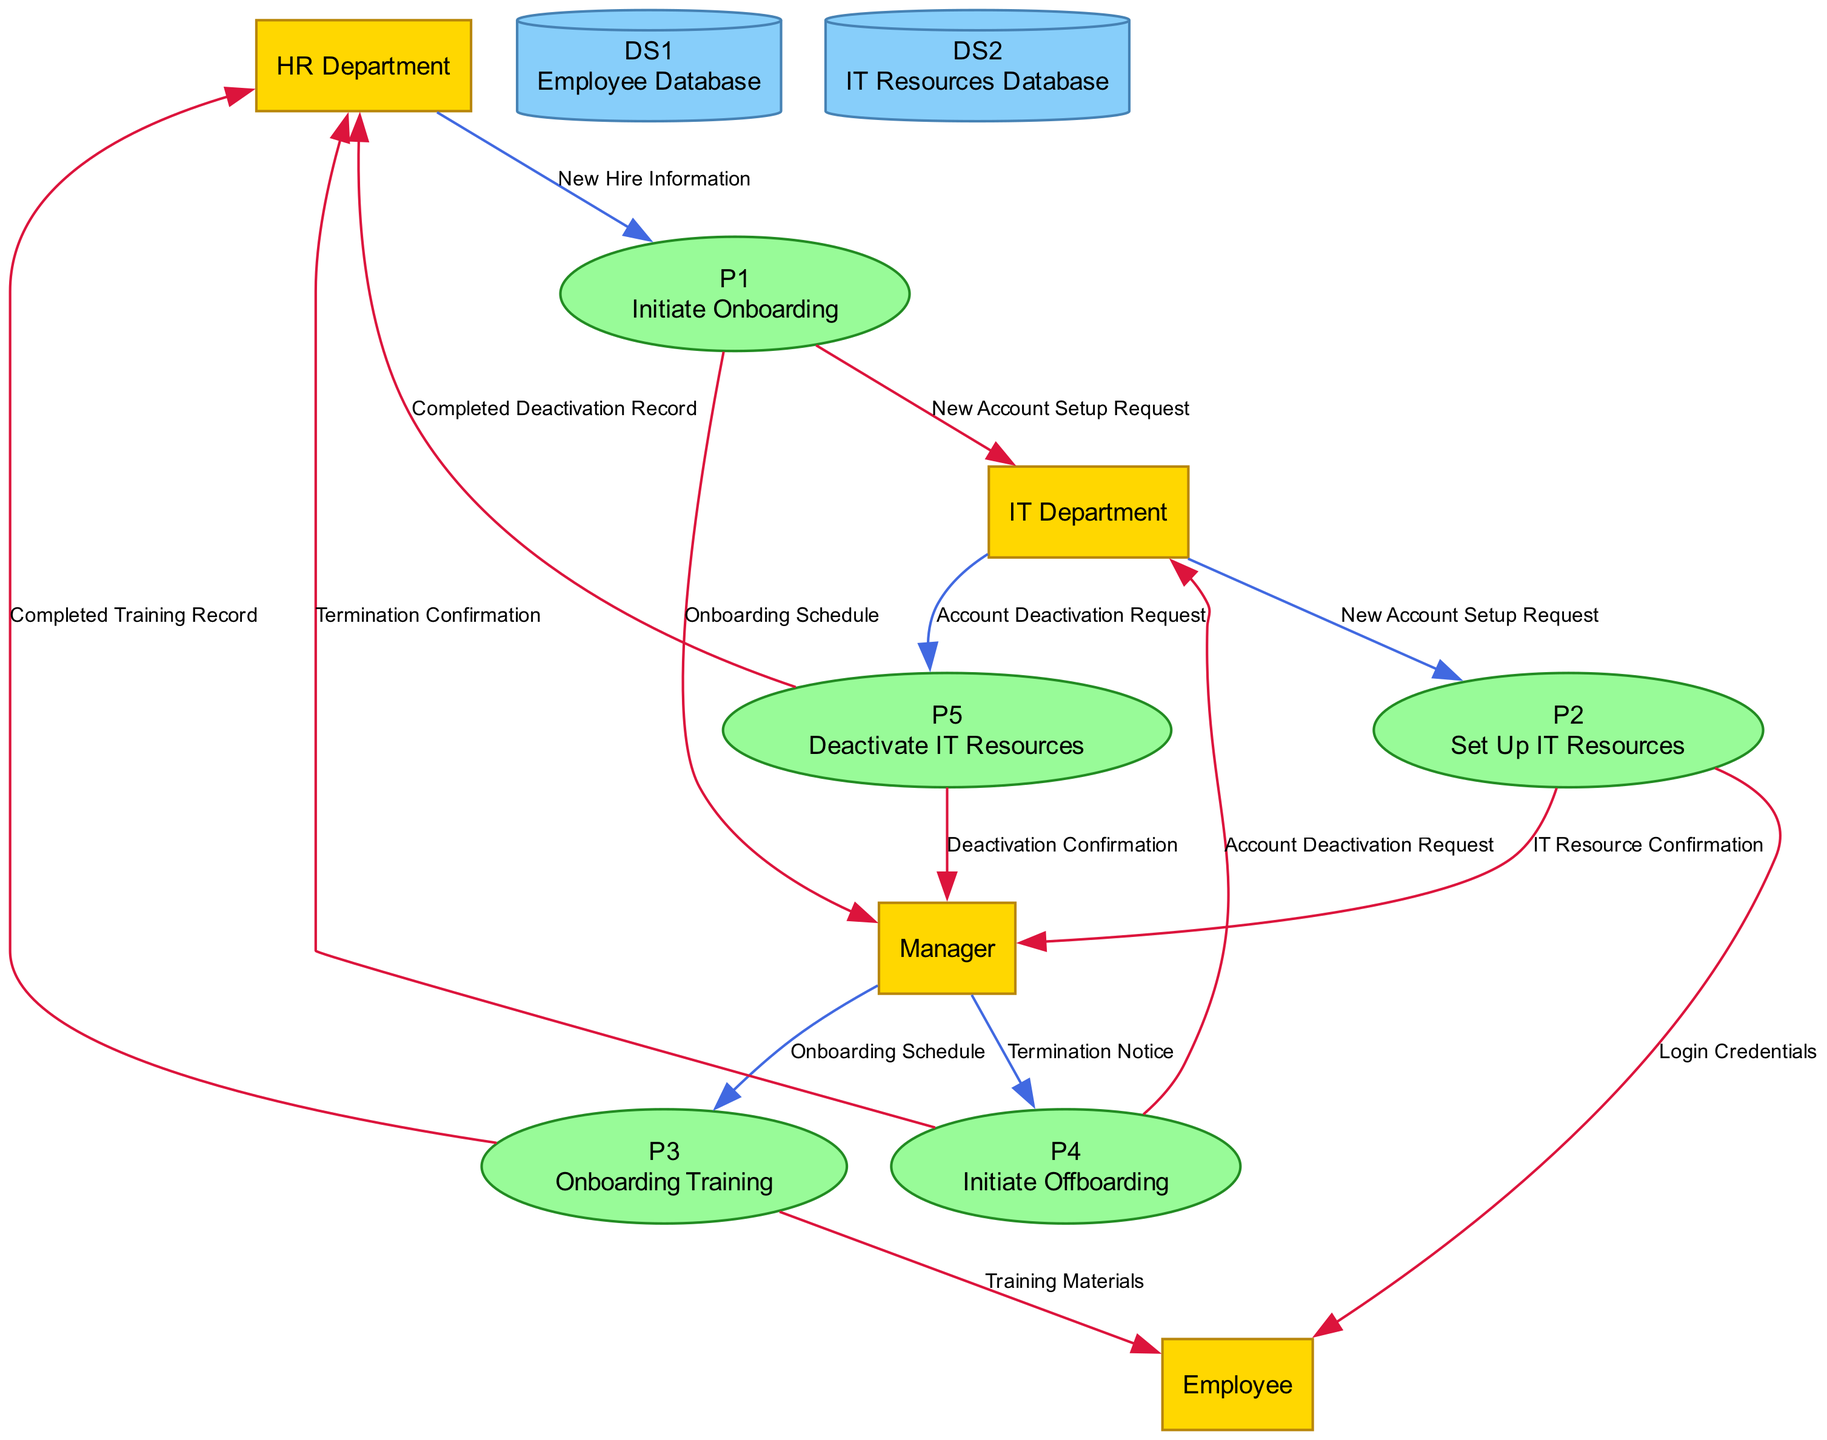What is the input for the "Initiate Onboarding" process? The input for the "Initiate Onboarding" process is provided by the HR Department and consists of "New Hire Information".
Answer: New Hire Information How many external entities are present in the diagram? There are four external entities in the diagram: HR Department, IT Department, Employee, and Manager.
Answer: 4 What does the "Set Up IT Resources" process output to the Employee? The "Set Up IT Resources" process outputs "Login Credentials" to the Employee.
Answer: Login Credentials Which entity receives the "Account Deactivation Request"? The entity that receives the "Account Deactivation Request" is the IT Department.
Answer: IT Department What is the output of the "Deactivate IT Resources" process? The "Deactivate IT Resources" process outputs "Deactivation Confirmation" to the Manager and "Completed Deactivation Record" to the HR Department.
Answer: Deactivation Confirmation, Completed Deactivation Record What data is used as input for the "Onboarding Training" process? The input for the "Onboarding Training" process is the "Onboarding Schedule" provided by the Manager.
Answer: Onboarding Schedule Which process generates an output to both HR Department and Manager? The process "Initiate Onboarding" generates outputs to both the HR Department (Termination Confirmation) and the Manager (IT Resource Confirmation) during offboarding.
Answer: Initiate Onboarding How many processes are part of the workflow? There are five processes that are part of the workflow: Initiate Onboarding, Set Up IT Resources, Onboarding Training, Initiate Offboarding, and Deactivate IT Resources.
Answer: 5 What is the name of the data store that contains "Employee Records"? The data store that contains "Employee Records" is named "Employee Database".
Answer: Employee Database 